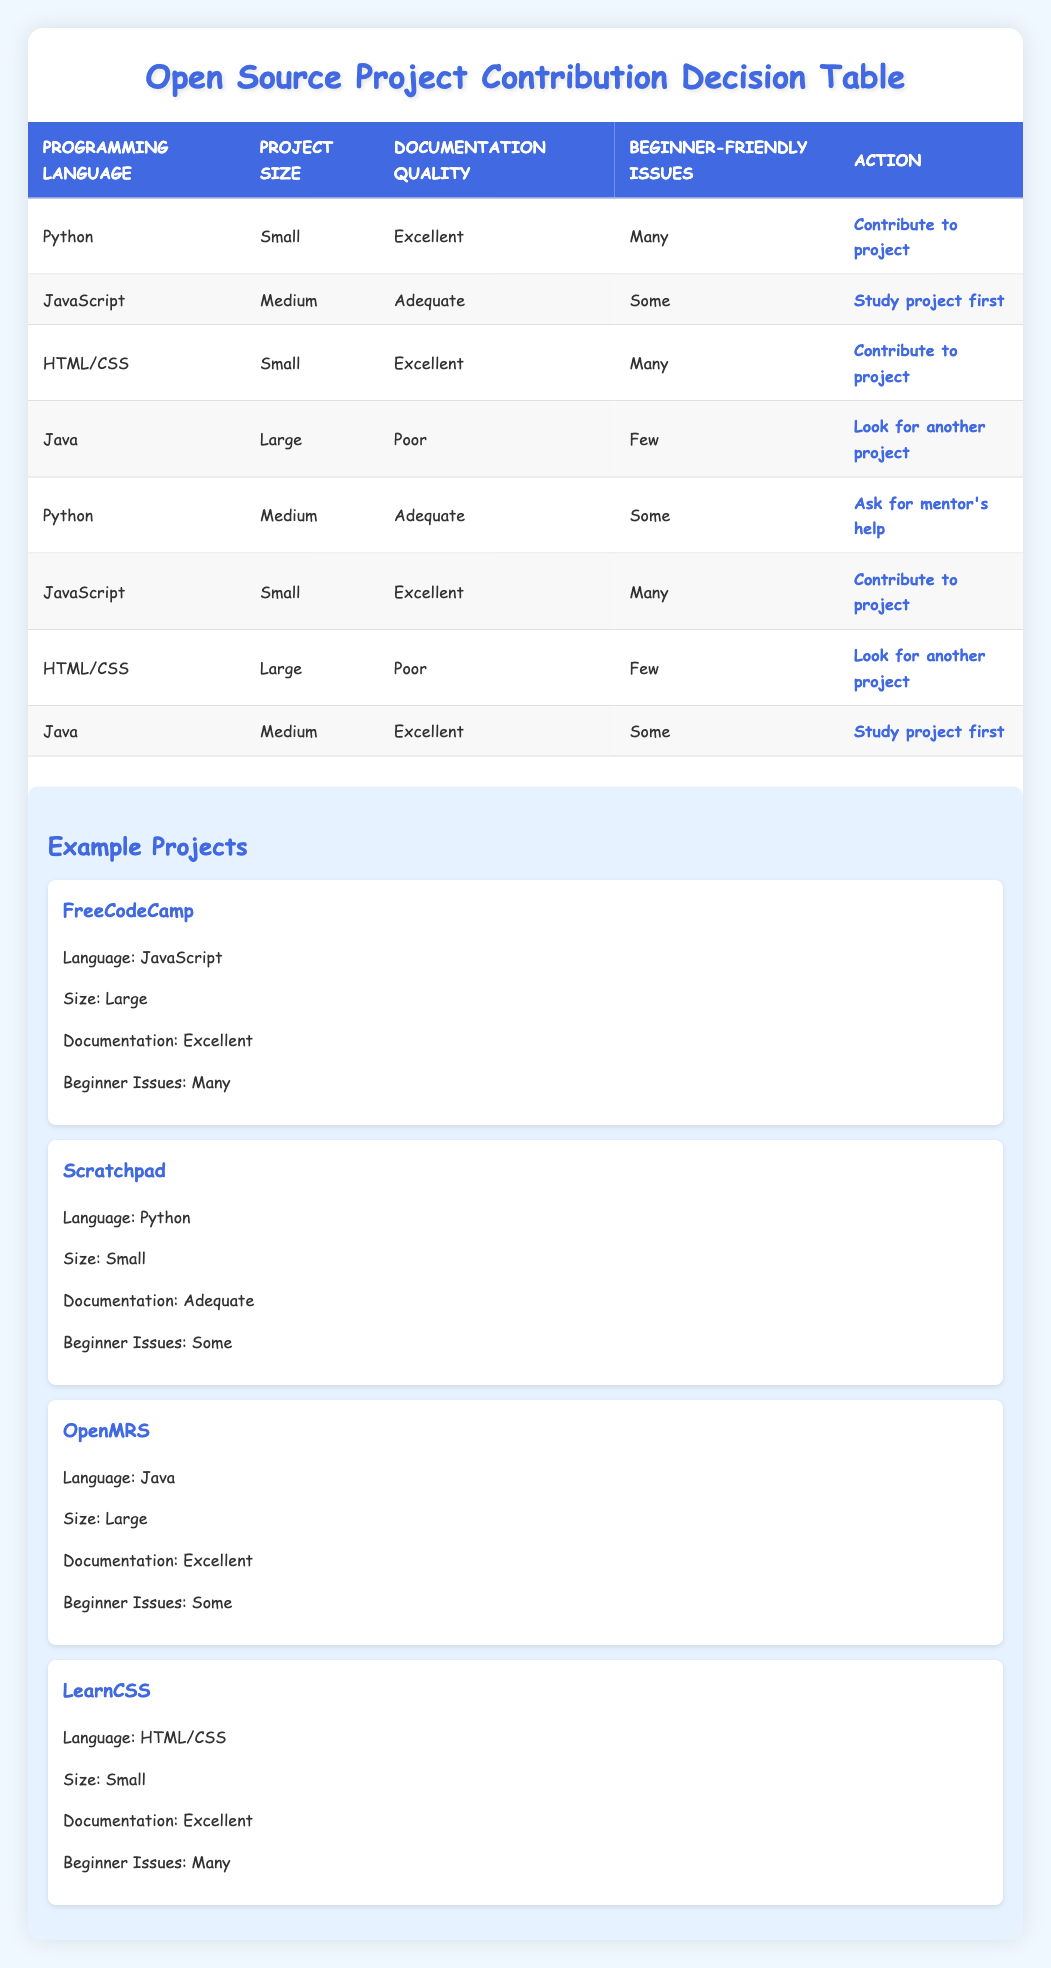What action should be taken for a Python project that is small, has excellent documentation, and many beginner-friendly issues? According to the table, if a project meets these criteria (Python, Small, Excellent, Many), the action specified is "Contribute to project."
Answer: Contribute to project What is the action for a Java project that is large, has poor documentation, and few beginner-friendly issues? The table states that for a Java project that is large, with poor documentation, and few beginner-friendly issues, the action to take is "Look for another project."
Answer: Look for another project How many different actions are listed in the table? The table lists a total of four different actions: "Contribute to project," "Look for another project," "Study project first," and "Ask for mentor's help." Hence, there are four unique actions.
Answer: Four Is there a JavaScript project with excellent documentation and many beginner-friendly issues? Reviewing the table, there is indeed a JavaScript project that is small, has excellent documentation, and many beginner-friendly issues, which corresponds to the action "Contribute to project." Therefore, the answer is yes.
Answer: Yes For projects with adequate documentation, how many total beginner-friendly issues do they have? There are two entries with adequate documentation: one Python project with "Some" issues and one Java project with "Some" issues. Since both have the same value ("Some"), we can conclude that they have a total of "Some."
Answer: Some What action should be taken for a large HTML/CSS project with poor documentation and few beginner issues? The table specifies that for a large HTML/CSS project that has poor documentation and few beginner issues, the action to take is "Look for another project."
Answer: Look for another project How many projects use Python as their programming language, and what actions are recommended for them? There are two projects that use Python: one is small, has excellent documentation, and many beginner-friendly issues which leads to the action "Contribute to project," and the other is medium, has adequate documentation, and some beginner-friendly issues which leads to "Ask for mentor's help."
Answer: Two projects; actions: "Contribute to project," "Ask for mentor's help." Does every programming language listed have at least one associated action for project contribution? Inspecting the table, you can see that all programming languages (Python, JavaScript, HTML/CSS, and Java) have corresponding actions associated with them based on different conditions, making the answer yes.
Answer: Yes What is the most common action recommended for projects classified as small? The table indicates that small projects lead to various actions: Python (Contribute), HTML/CSS (Contribute), and JavaScript (Contribute), while only JavaScript has a medium classification leading to "Study project first." Thus, the common action among small projects is "Contribute to project."
Answer: Contribute to project 